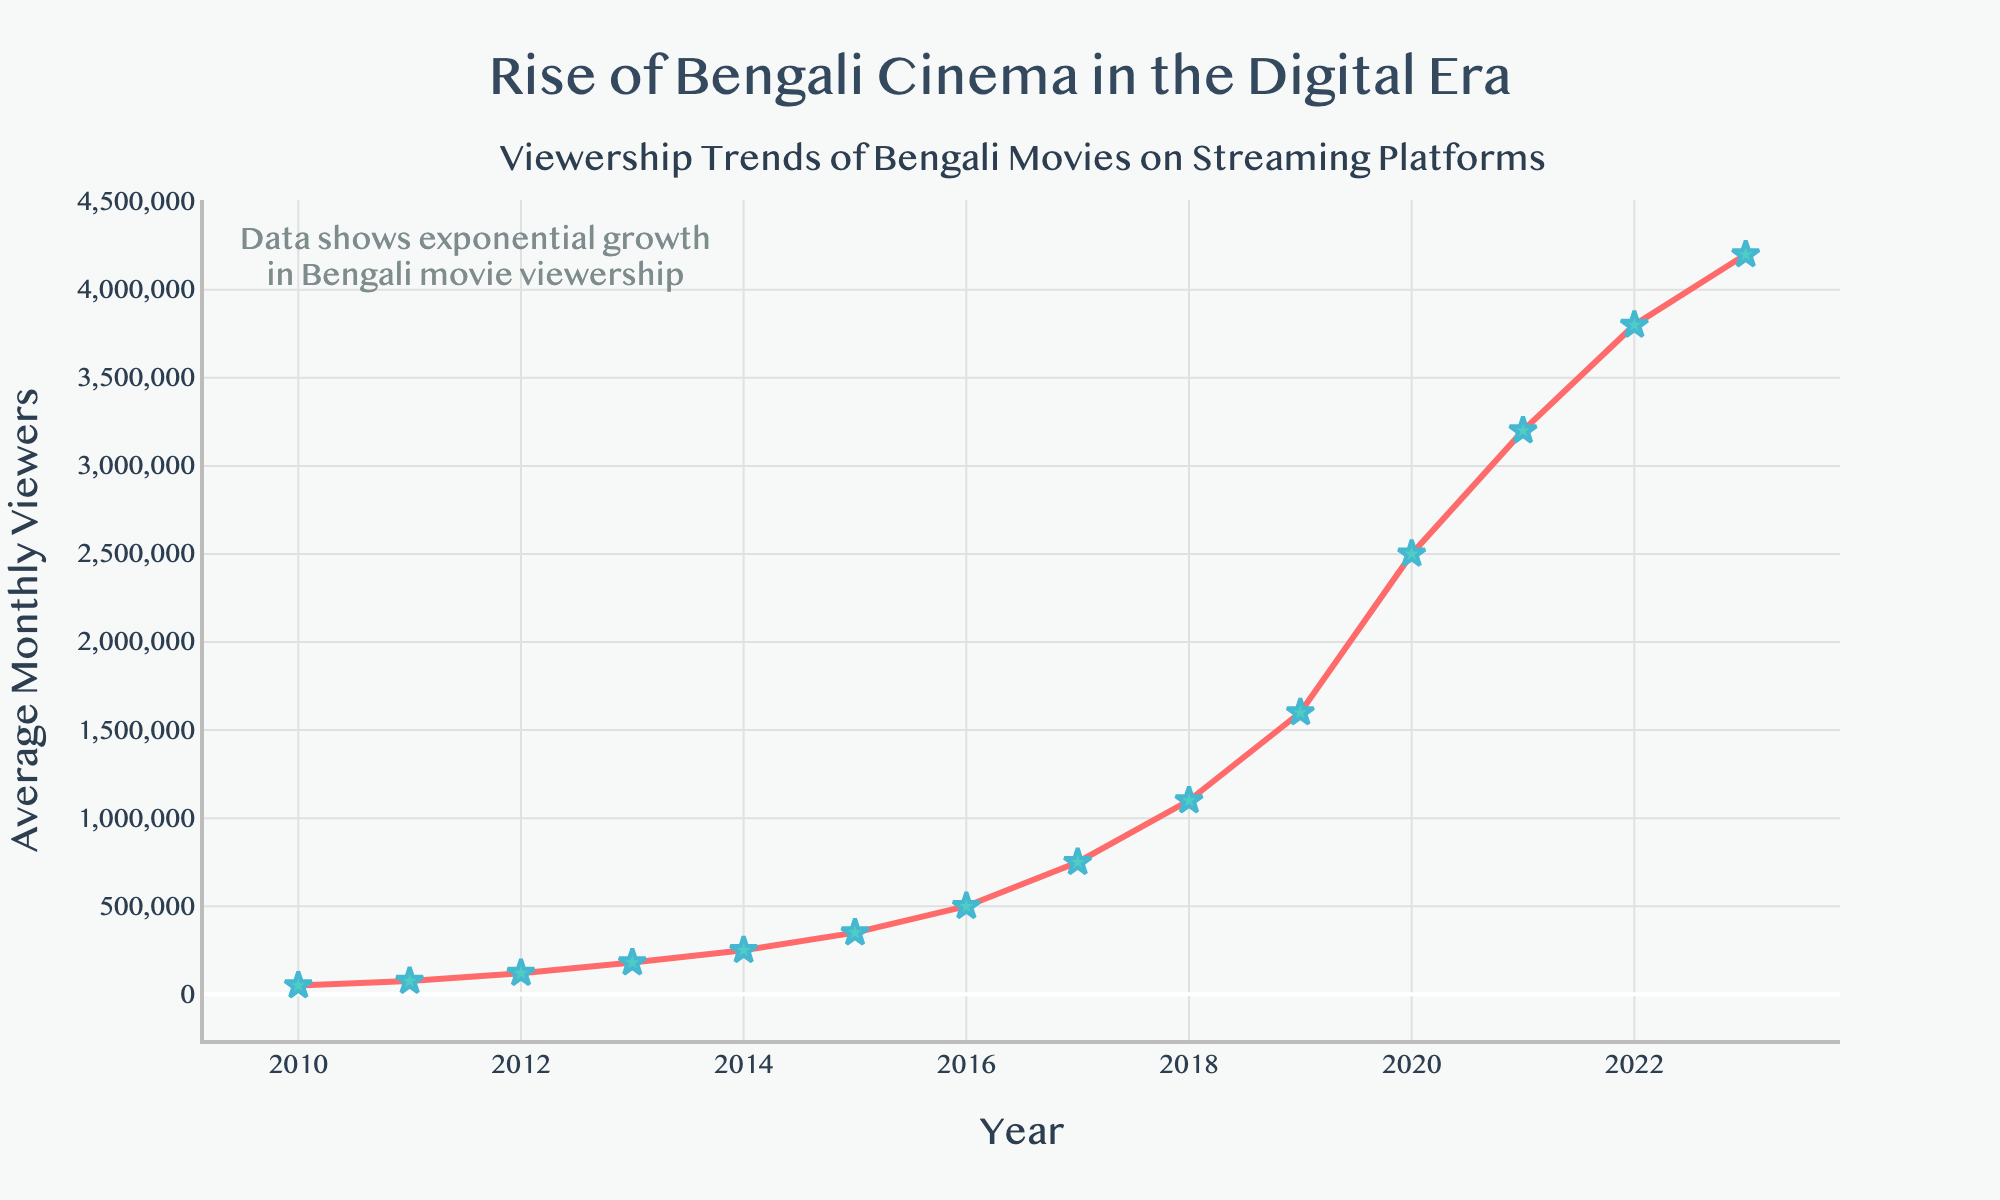what is the trend of average monthly viewers from 2010 to 2023? The figure shows a line plot tracking the number of average monthly viewers from 2010 to 2023. From a visual inspection, there is a continuous upward trend, indicating a consistent increase in viewership over the years. The viewership starts modestly in 2010 and rises steeply towards 2023.
Answer: Increasing What was the average monthly viewership in 2020? By referring to the data points plotted on the figure, we can see that the average monthly viewership for the year 2020 is represented as 2,500,000.
Answer: 2,500,000 Compare the viewership growth between 2010 and 2015. By how much did the viewership increase? From the figure, the average monthly viewers in 2010 is 50,000 and in 2015 it is 350,000. To find the increase, we subtract the 2010 value from the 2015 value: 350,000 - 50,000 = 300,000.
Answer: 300,000 What is the average annual growth rate of viewership between 2010 and 2023? The viewer counts in 2010 and 2023 are 50,000 and 4,200,000 respectively. First, calculate the total increase: 4,200,000 - 50,000 = 4,150,000. Then divide this by the number of years (2023 - 2010 = 13) to find the average annual increase: 4,150,000 ÷ 13 ≈ 319,231 viewers per year.
Answer: 319,231 Identify the year with the highest single-year growth in viewership and quantify the growth. By analyzing the slope of the line plot between each pair of consecutive years, the largest increase occurred between 2019 and 2020. In 2019, the viewers were 1,600,000, and in 2020, the viewers increased to 2,500,000. The growth is thus 2,500,000 - 1,600,000 = 900,000 viewers.
Answer: 2019-2020, 900,000 Which year saw the viewership cross one million for the first time? The plotted data shows that the viewership first exceeds one million in 2018. The marked point for 2018 shows 1,100,000 viewers.
Answer: 2018 Considering the overall trend from 2010 to 2023, predict the potential viewership in 2025 assuming the growth pattern remains the same. To predict, observe the recent growth pattern in the plot. From 2021 to 2023, the growth was 1,000,000 per year (from 3,200,000 to 4,200,000 across 2 years). Assuming a modest growth rate of 1,000,000 annually: for 2024 it would be 4,200,000 + 1,000,000 = 5,200,000, and for 2025 it would be 5,200,000 + 1,000,000 = 6,200,000 viewers.
Answer: 6,200,000 